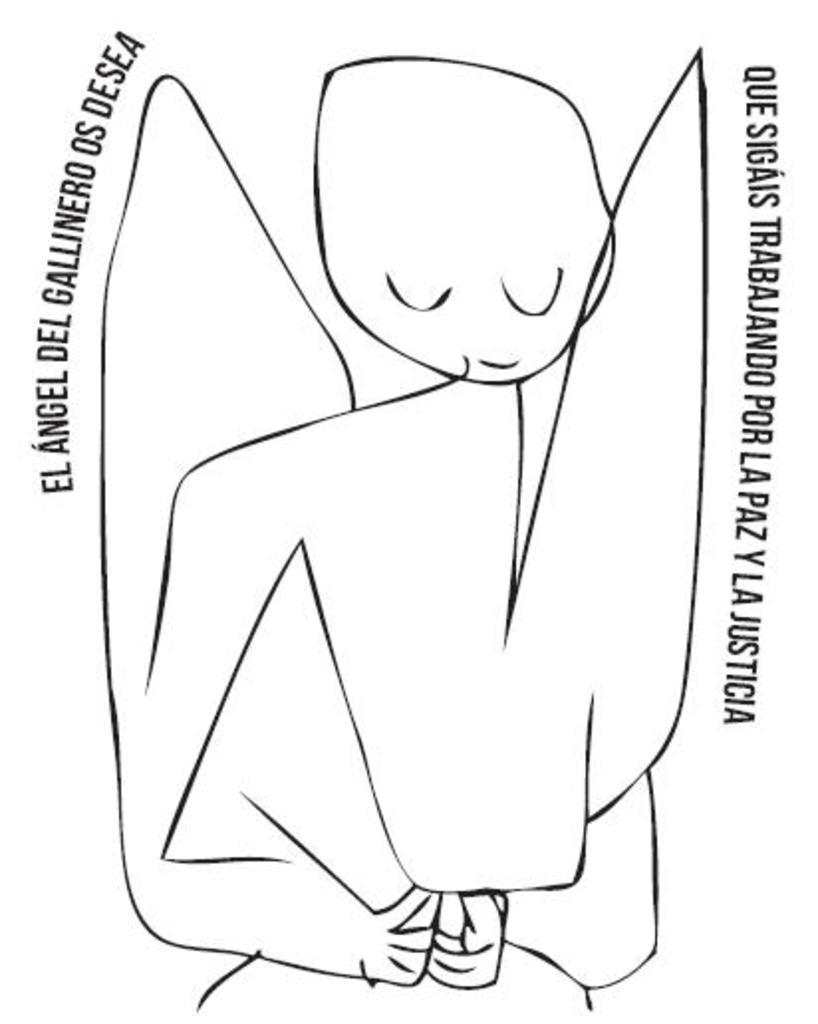What is the primary visual element in the image? There is a sketch in the image. What other type of content is present in the image? There is text in the image. What type of arm is depicted in the sketch in the image? There is no arm depicted in the sketch in the image. What kind of cave is shown in the background of the sketch? There is no cave present in the image, as it only contains a sketch and text. 